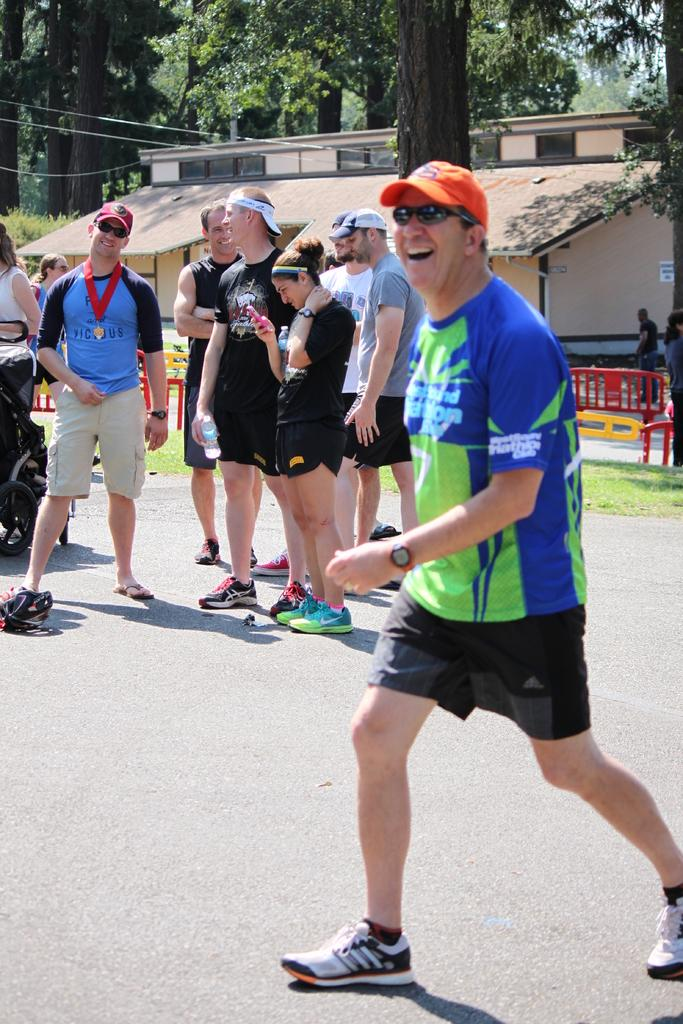What is the main subject in the center of the image? There is a group of people in the center of the image. What is located behind the group of people? There is a boundary behind the group of people. What can be seen in the background of the image? There is a house and trees in the background of the image. How many books are being controlled by the group of people in the image? There are no books present in the image, and the group of people is not controlling any books. 